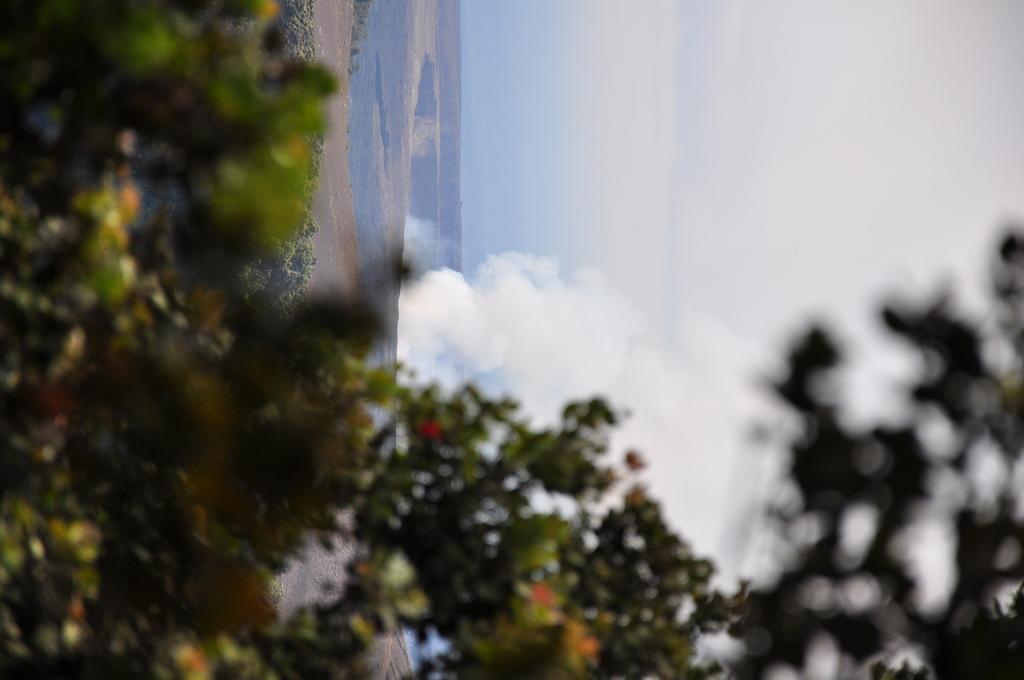In one or two sentences, can you explain what this image depicts? In this image at front there are trees. At the back side there is smoke coming out of the hole and at the background there is sky. 